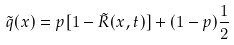Convert formula to latex. <formula><loc_0><loc_0><loc_500><loc_500>\tilde { q } ( x ) = p [ 1 - \tilde { R } ( x , t ) ] + ( 1 - p ) \frac { 1 } { 2 }</formula> 